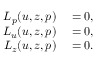<formula> <loc_0><loc_0><loc_500><loc_500>\begin{array} { r l } { L _ { p } ( u , z , p ) } & = 0 , } \\ { L _ { u } ( u , z , p ) } & = 0 , } \\ { L _ { z } ( u , z , p ) } & = 0 . } \end{array}</formula> 